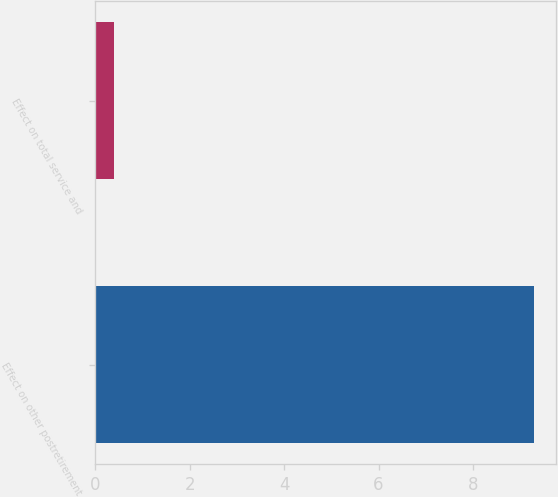<chart> <loc_0><loc_0><loc_500><loc_500><bar_chart><fcel>Effect on other postretirement<fcel>Effect on total service and<nl><fcel>9.3<fcel>0.4<nl></chart> 